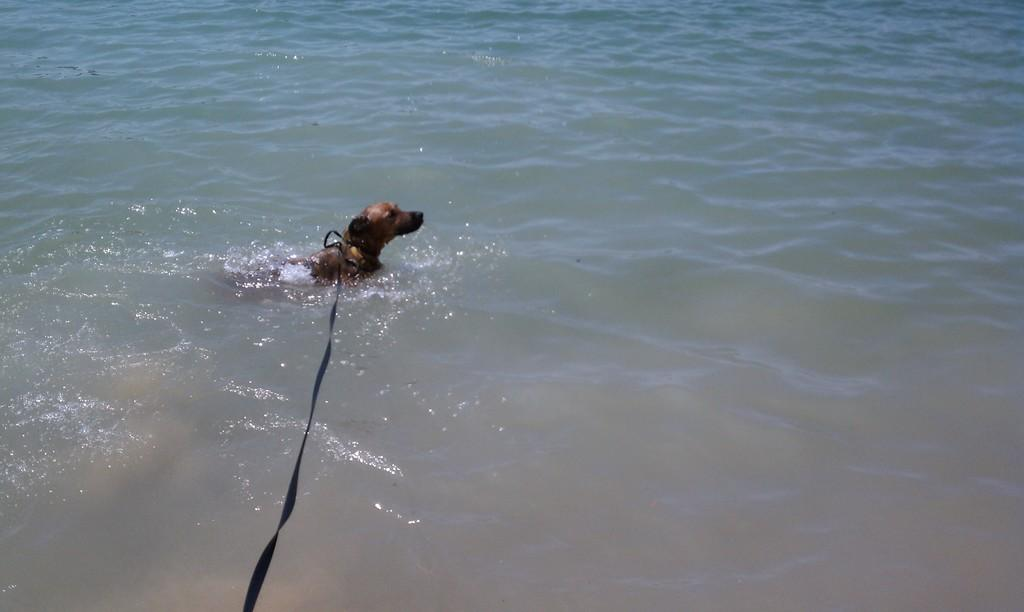What animal is present in the image? There is a dog in the image. Where is the dog located? The dog is in the water. Is the dog attached to anything in the image? Yes, the dog is tied with a black belt. What type of tray can be seen floating near the dog in the image? There is no tray present in the image; it only features a dog in the water tied with a black belt. 